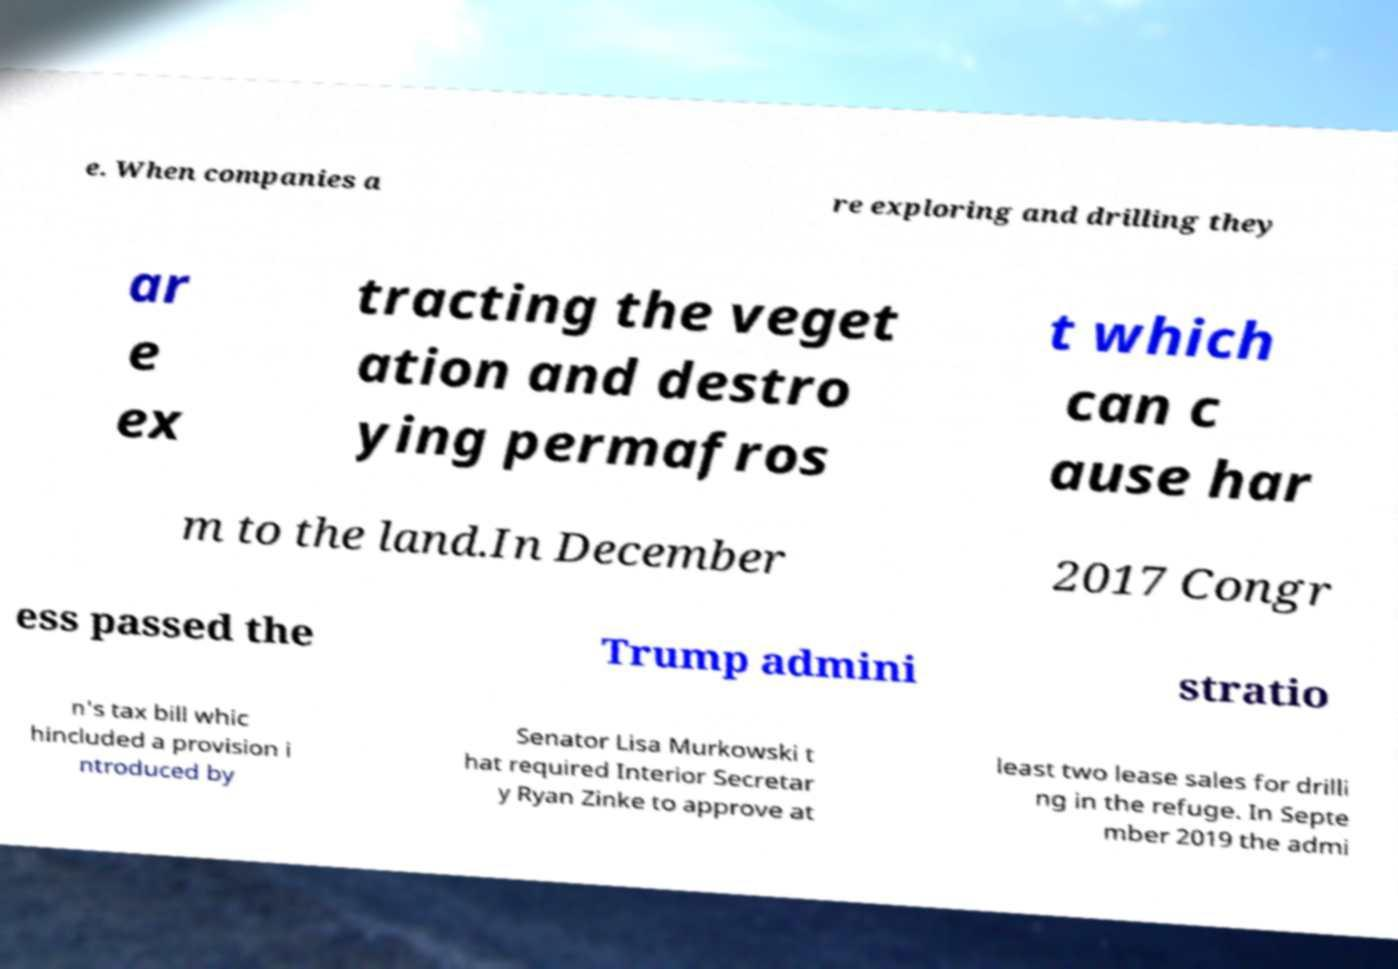For documentation purposes, I need the text within this image transcribed. Could you provide that? e. When companies a re exploring and drilling they ar e ex tracting the veget ation and destro ying permafros t which can c ause har m to the land.In December 2017 Congr ess passed the Trump admini stratio n's tax bill whic hincluded a provision i ntroduced by Senator Lisa Murkowski t hat required Interior Secretar y Ryan Zinke to approve at least two lease sales for drilli ng in the refuge. In Septe mber 2019 the admi 